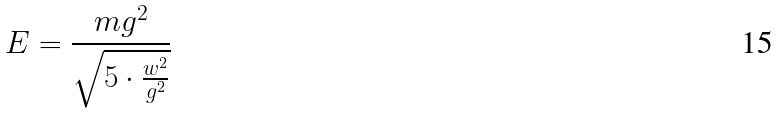Convert formula to latex. <formula><loc_0><loc_0><loc_500><loc_500>E = \frac { m g ^ { 2 } } { \sqrt { 5 \cdot \frac { w ^ { 2 } } { g ^ { 2 } } } }</formula> 